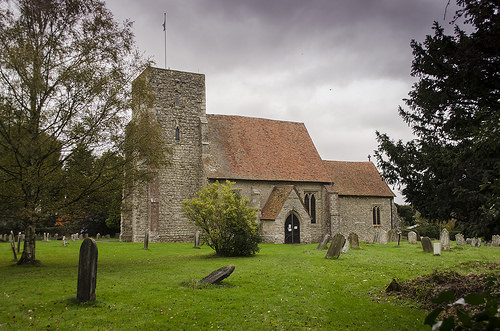<image>
Can you confirm if the gravestone is behind the tree? No. The gravestone is not behind the tree. From this viewpoint, the gravestone appears to be positioned elsewhere in the scene. 